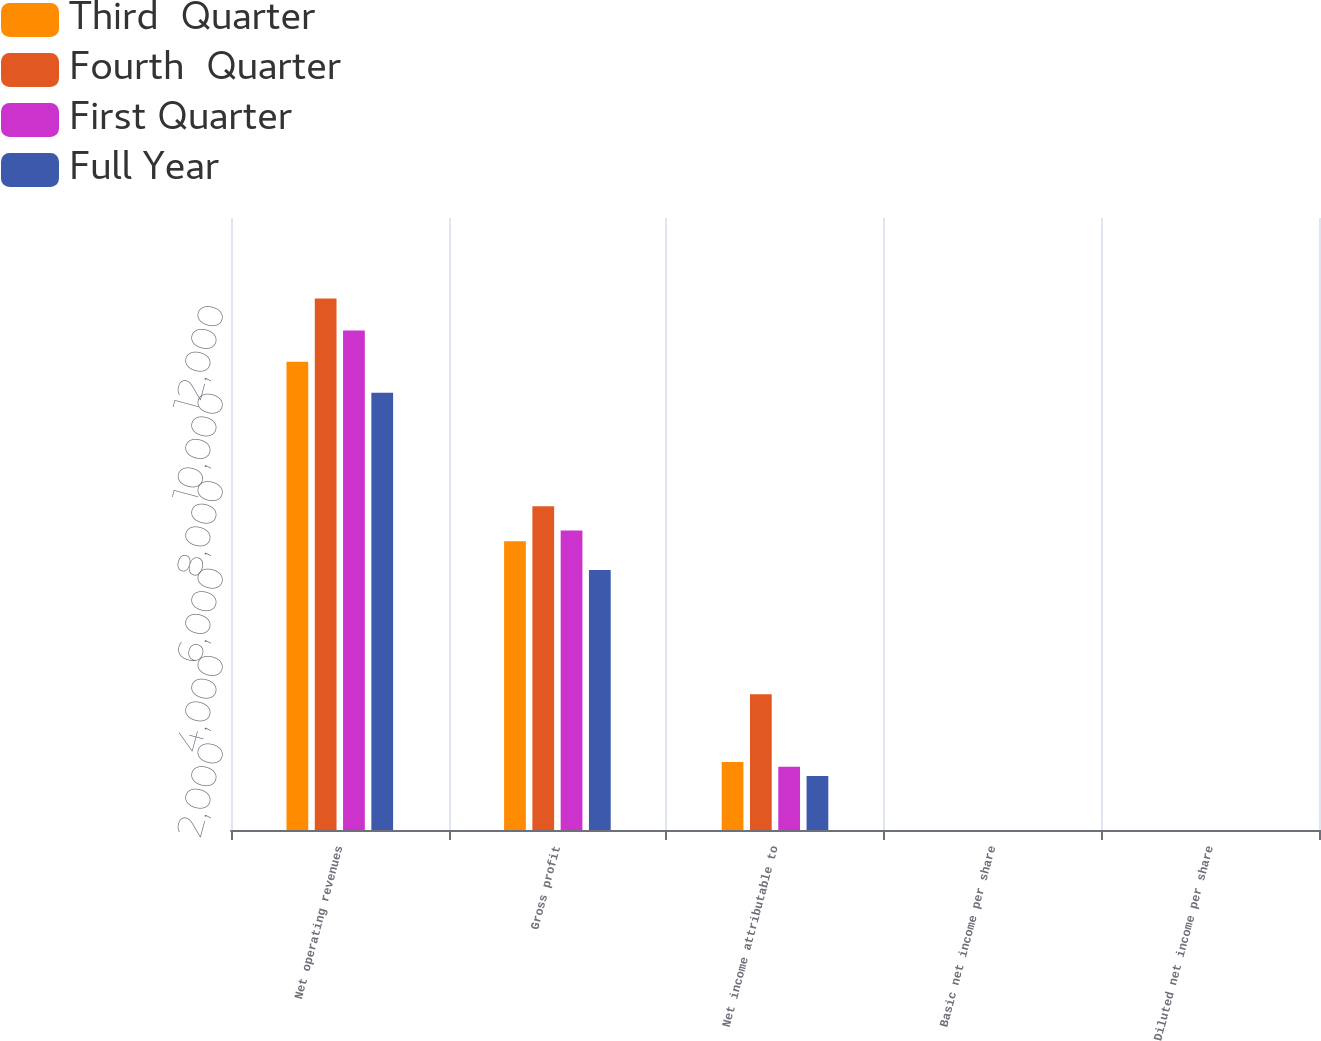Convert chart to OTSL. <chart><loc_0><loc_0><loc_500><loc_500><stacked_bar_chart><ecel><fcel>Net operating revenues<fcel>Gross profit<fcel>Net income attributable to<fcel>Basic net income per share<fcel>Diluted net income per share<nl><fcel>Third  Quarter<fcel>10711<fcel>6608<fcel>1557<fcel>0.36<fcel>0.35<nl><fcel>Fourth  Quarter<fcel>12156<fcel>7408<fcel>3108<fcel>0.71<fcel>0.71<nl><fcel>First Quarter<fcel>11427<fcel>6850<fcel>1449<fcel>0.33<fcel>0.33<nl><fcel>Full Year<fcel>10000<fcel>5946<fcel>1237<fcel>0.29<fcel>0.28<nl></chart> 